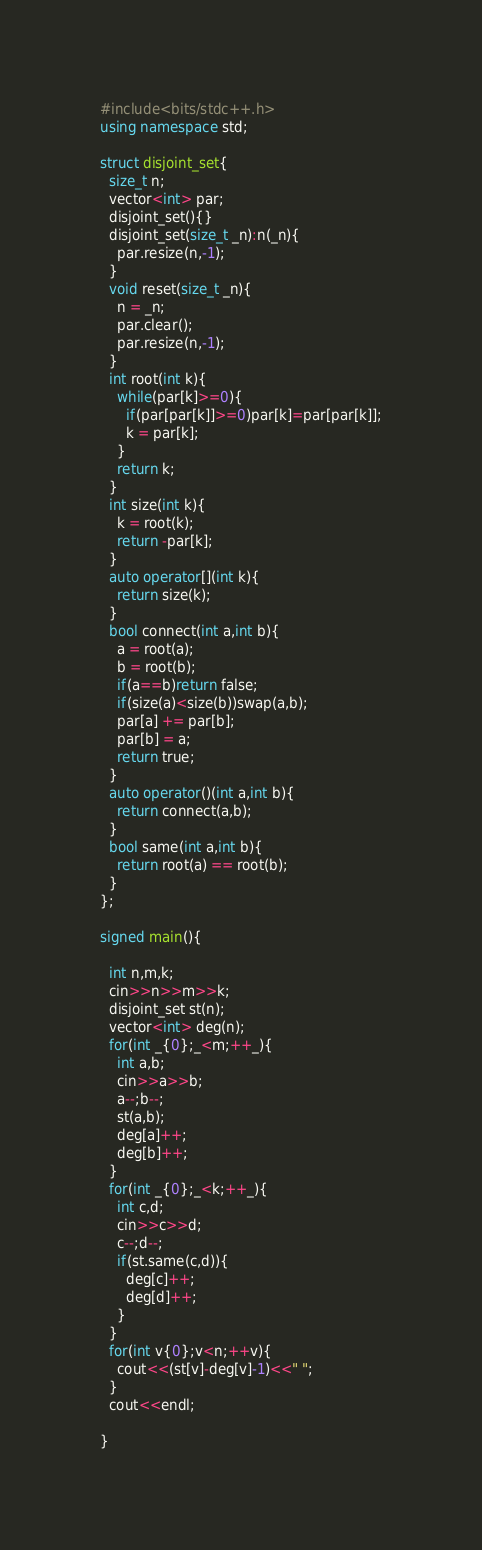Convert code to text. <code><loc_0><loc_0><loc_500><loc_500><_C++_>#include<bits/stdc++.h>
using namespace std;

struct disjoint_set{
  size_t n;
  vector<int> par;
  disjoint_set(){}
  disjoint_set(size_t _n):n(_n){
    par.resize(n,-1);
  }
  void reset(size_t _n){
    n = _n;
    par.clear();
    par.resize(n,-1);
  }
  int root(int k){
    while(par[k]>=0){
      if(par[par[k]]>=0)par[k]=par[par[k]];
      k = par[k];
    }
    return k;
  }
  int size(int k){
    k = root(k);
    return -par[k];
  }
  auto operator[](int k){
    return size(k);
  }
  bool connect(int a,int b){
    a = root(a);
    b = root(b);
    if(a==b)return false;
    if(size(a)<size(b))swap(a,b);
    par[a] += par[b];
    par[b] = a;
    return true;
  }
  auto operator()(int a,int b){
    return connect(a,b);
  }
  bool same(int a,int b){
    return root(a) == root(b);
  }
};

signed main(){

  int n,m,k;
  cin>>n>>m>>k;
  disjoint_set st(n);
  vector<int> deg(n);
  for(int _{0};_<m;++_){
    int a,b;
    cin>>a>>b;
    a--;b--;
    st(a,b);
    deg[a]++;
    deg[b]++;
  }
  for(int _{0};_<k;++_){
    int c,d;
    cin>>c>>d;
    c--;d--;
    if(st.same(c,d)){
      deg[c]++;
      deg[d]++;
    }
  }
  for(int v{0};v<n;++v){
    cout<<(st[v]-deg[v]-1)<<" ";
  }
  cout<<endl;

}</code> 